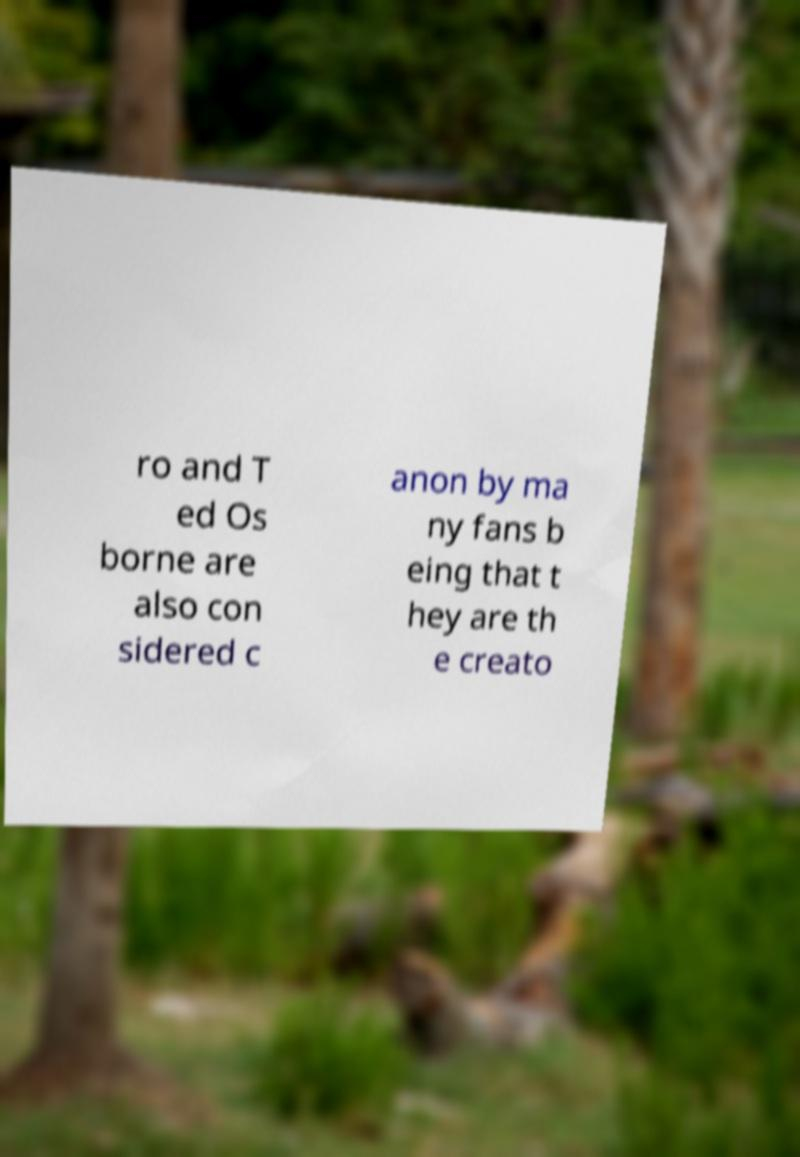Please read and relay the text visible in this image. What does it say? ro and T ed Os borne are also con sidered c anon by ma ny fans b eing that t hey are th e creato 